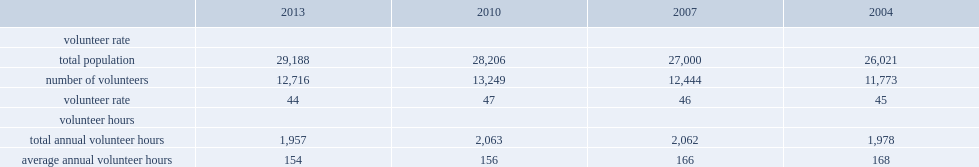What is the rate of canadians aged 15 years and older reporting volunteering in 2013? 44.0. How many canadians aged 15 years and older reporting volunteering in 2013? 12716.0. In which year is the volunteer rate lower, 2010 or 2013? 2013.0. What is the number of volunteers in 2004? 11773.0. 